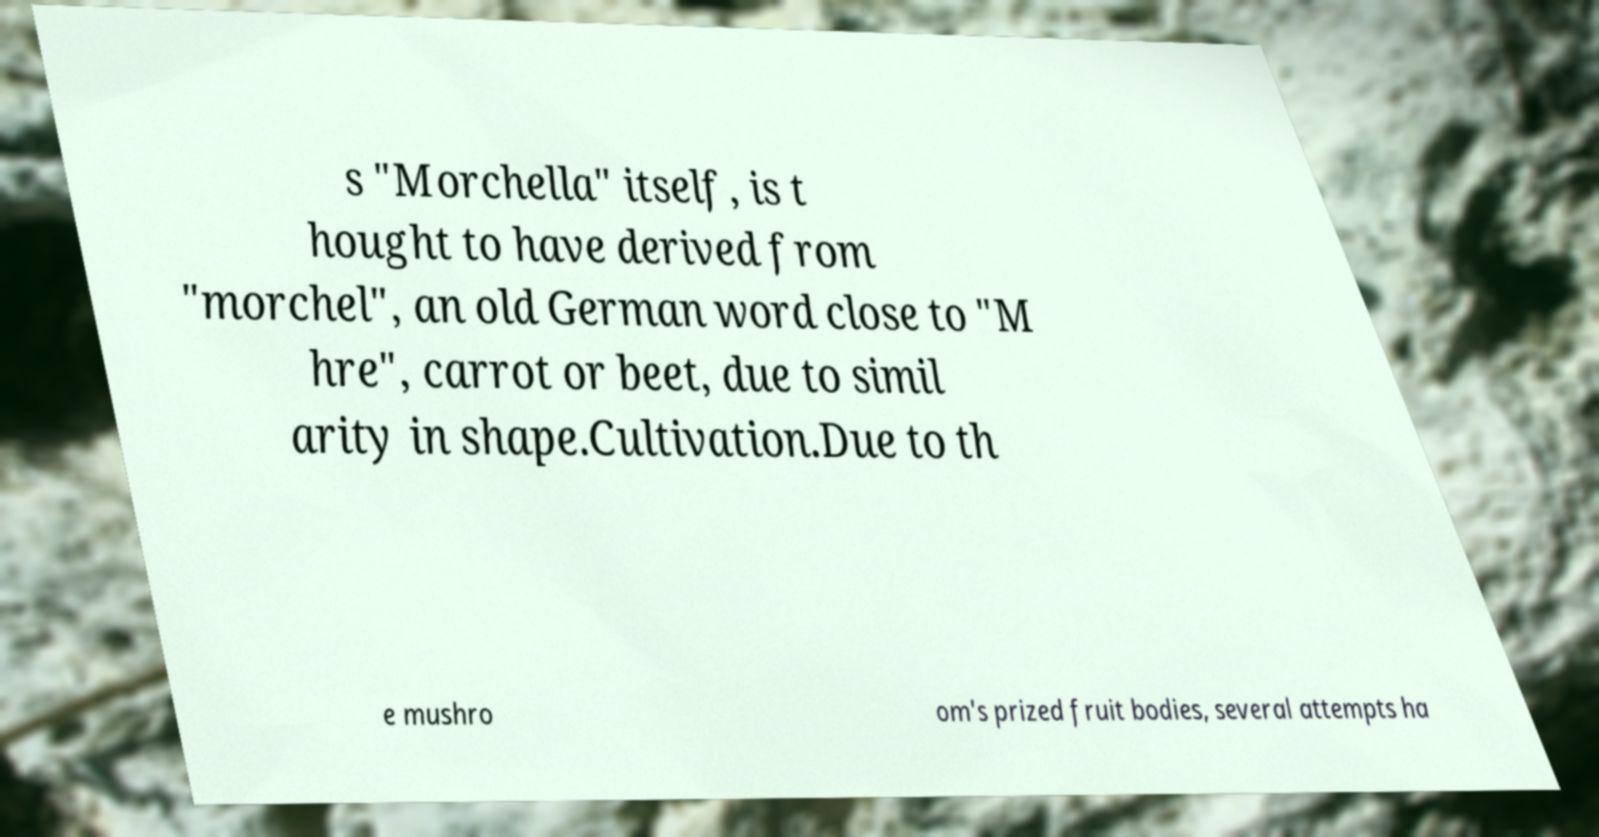I need the written content from this picture converted into text. Can you do that? s "Morchella" itself, is t hought to have derived from "morchel", an old German word close to "M hre", carrot or beet, due to simil arity in shape.Cultivation.Due to th e mushro om's prized fruit bodies, several attempts ha 